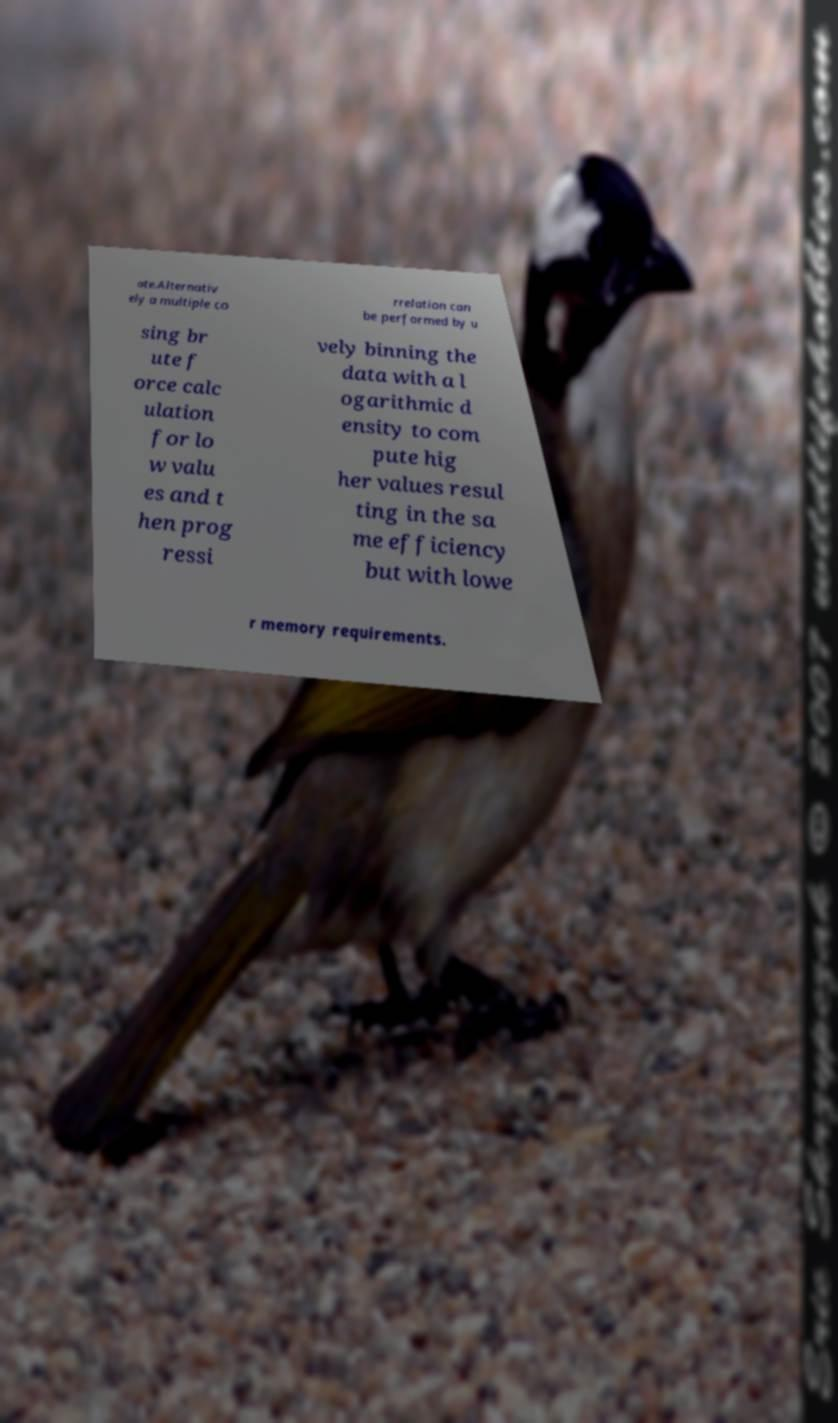Please read and relay the text visible in this image. What does it say? ate.Alternativ ely a multiple co rrelation can be performed by u sing br ute f orce calc ulation for lo w valu es and t hen prog ressi vely binning the data with a l ogarithmic d ensity to com pute hig her values resul ting in the sa me efficiency but with lowe r memory requirements. 